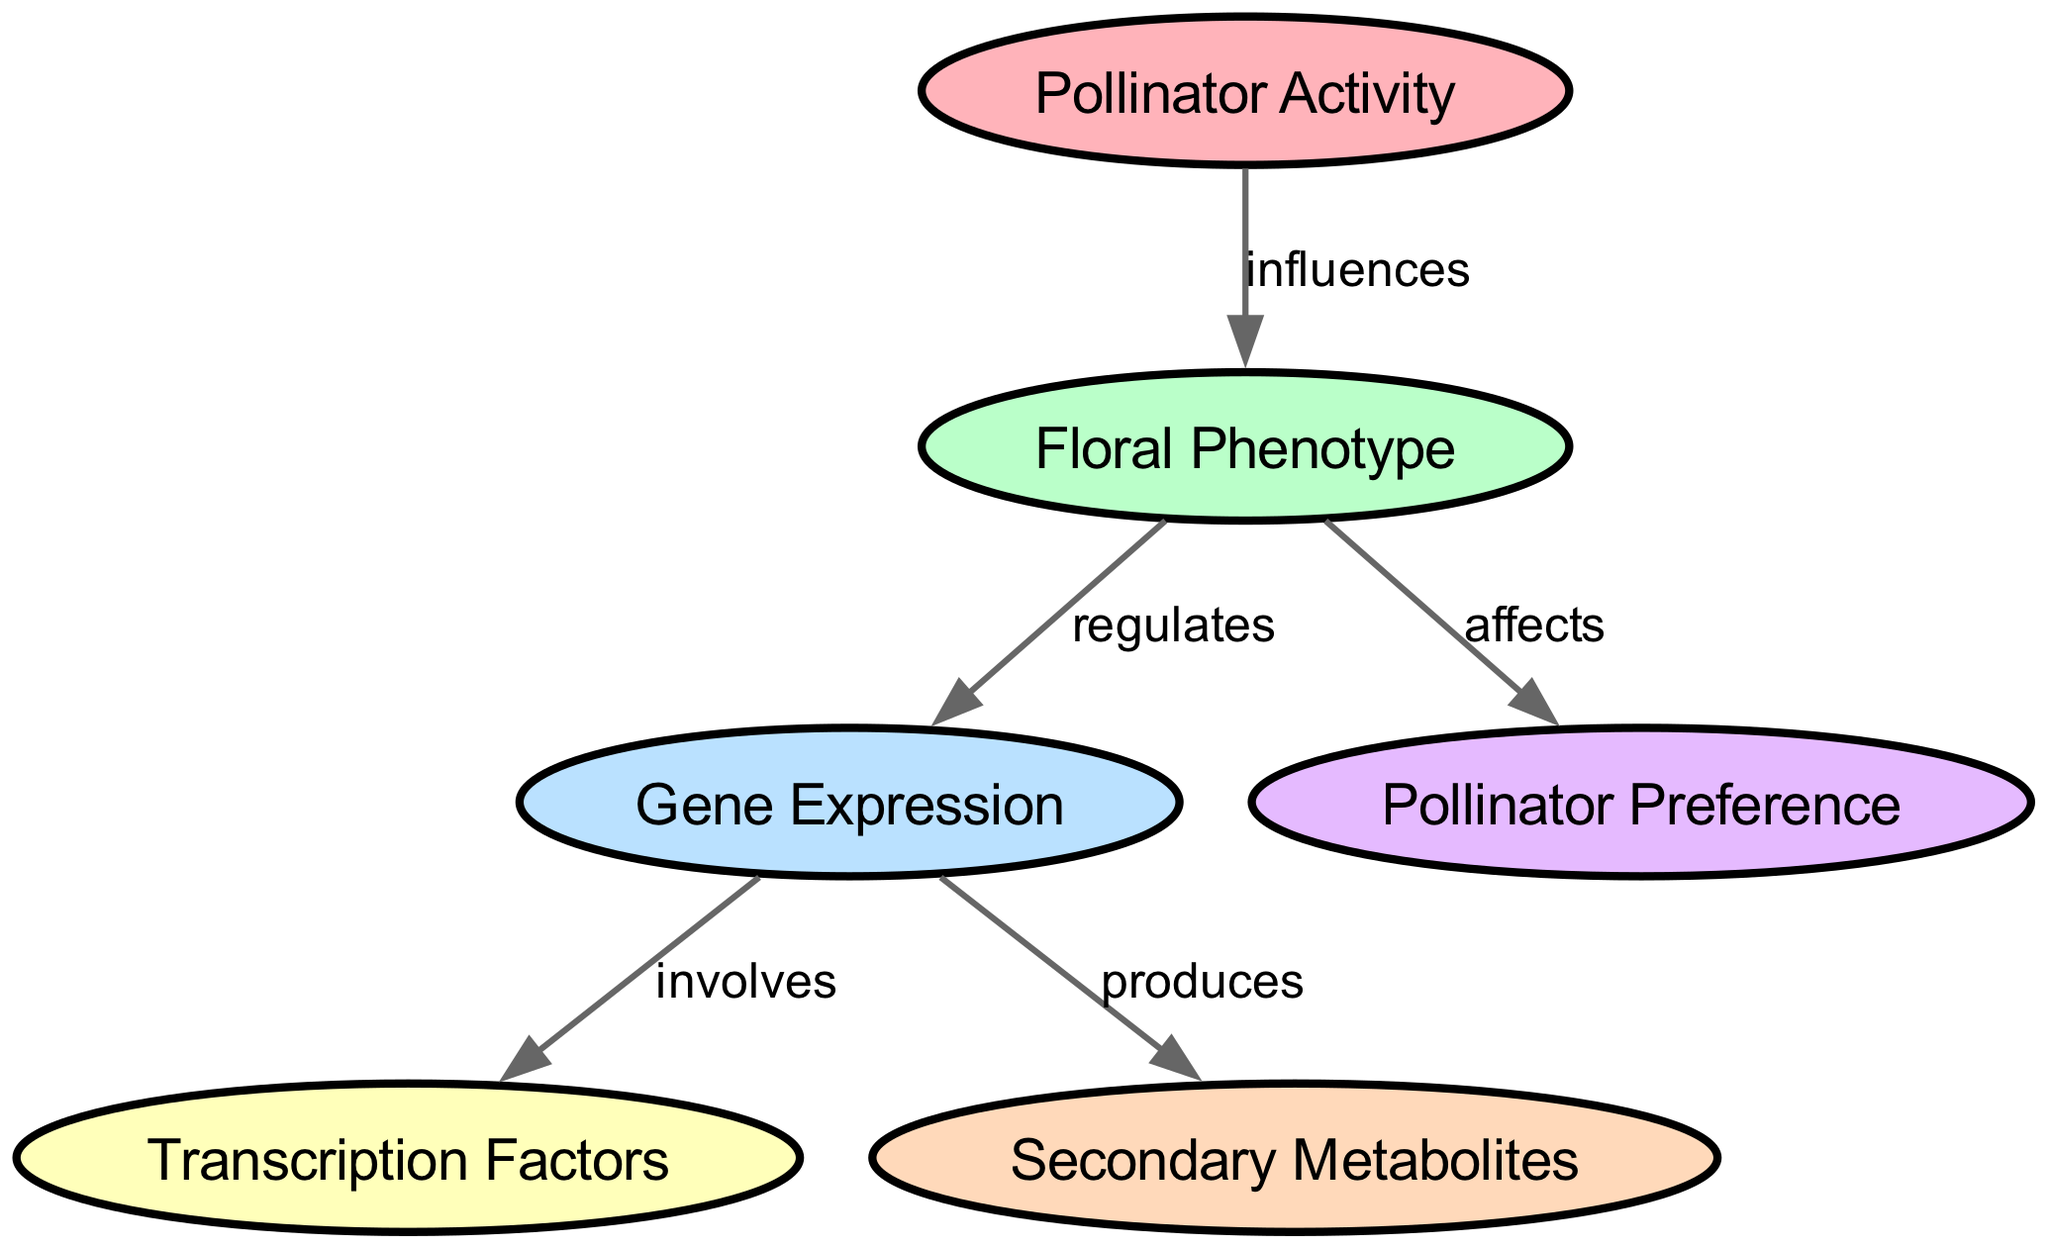What is the total number of nodes in the diagram? The diagram includes six nodes: Pollinator Activity, Floral Phenotype, Gene Expression, Transcription Factors, Secondary Metabolites, and Pollinator Preference. Counting these gives us a total of six nodes.
Answer: 6 What node does Pollinator Activity influence? The edge labeled "influences" connects Pollinator Activity to Floral Phenotype, indicating that Pollinator Activity has a direct impact on Floral Phenotype.
Answer: Floral Phenotype How many edges are present in the diagram? The diagram features five edges connecting the different nodes, specifically from Pollinator Activity to Floral Phenotype, Floral Phenotype to Gene Expression, Gene Expression to Transcription Factors, Gene Expression to Secondary Metabolites, and Floral Phenotype to Pollinator Preference.
Answer: 5 What does Gene Expression produce? There are two edges originating from Gene Expression, one of which is labeled "produces" and points to the Secondary Metabolites node. This indicates that Gene Expression is responsible for the production of Secondary Metabolites.
Answer: Secondary Metabolites Which node is affected by Floral Phenotype? The edge labeled "affects" extends from Floral Phenotype to Pollinator Preference, indicating that changes in Floral Phenotype have a direct effect on Pollinator Preference.
Answer: Pollinator Preference What is the relationship between Gene Expression and Transcription Factors? The edge labeled "involves" connects Gene Expression to Transcription Factors, suggesting that the process of Gene Expression includes or requires the participation of Transcription Factors.
Answer: involves If Pollinator Activity increases, what is the downstream effect on Pollinator Preference? According to the directed graph, Pollinator Activity influences Floral Phenotype, which subsequently affects Pollinator Preference. Therefore, an increase in Pollinator Activity would lead to changes in Pollinator Preference due to its influence on Floral Phenotype.
Answer: indirectly affects What is the primary role of Transcription Factors in the diagram? Transcription Factors are positioned as a result of Gene Expression and are connected through the edge labeled "involves." This implies that their primary role is to play a participatory role in the process of Gene Expression.
Answer: participatory role How many nodes are connected directly to Floral Phenotype? Floral Phenotype has three direct connections: one to Pollinator Activity (influences), one to Gene Expression (regulates), and one to Pollinator Preference (affects). Thus, it is connected to a total of three nodes directly.
Answer: 3 